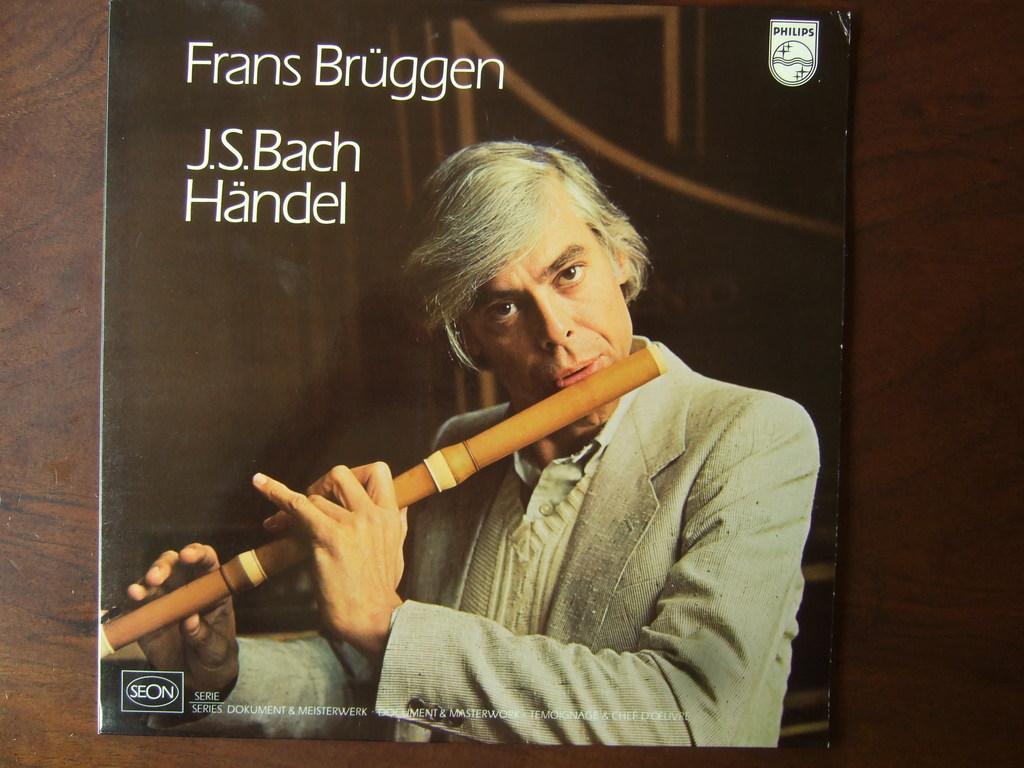How would you summarize this image in a sentence or two? This image consists of a poster. In which we can see a man playing a flute. In the background, there is a wall. And we can see a text on the poster. 